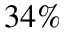Convert formula to latex. <formula><loc_0><loc_0><loc_500><loc_500>3 4 \%</formula> 